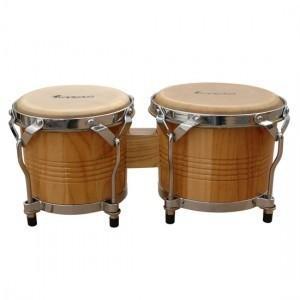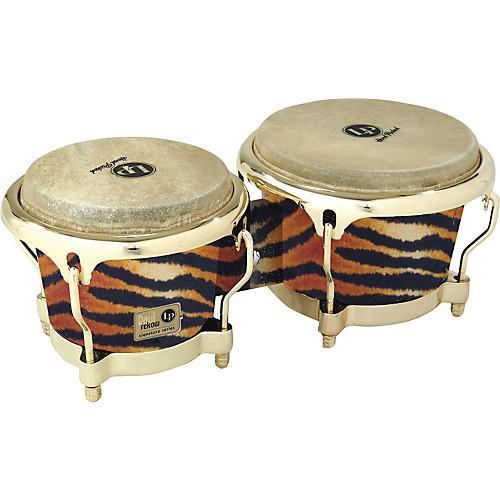The first image is the image on the left, the second image is the image on the right. Considering the images on both sides, is "There are two sets of bongo drums." valid? Answer yes or no. Yes. The first image is the image on the left, the second image is the image on the right. Given the left and right images, does the statement "Each image contains one connected, side-by-side pair of drums with short feet on each drum, and one of the drum pairs is brown with multiple parallel lines encircling it." hold true? Answer yes or no. Yes. 